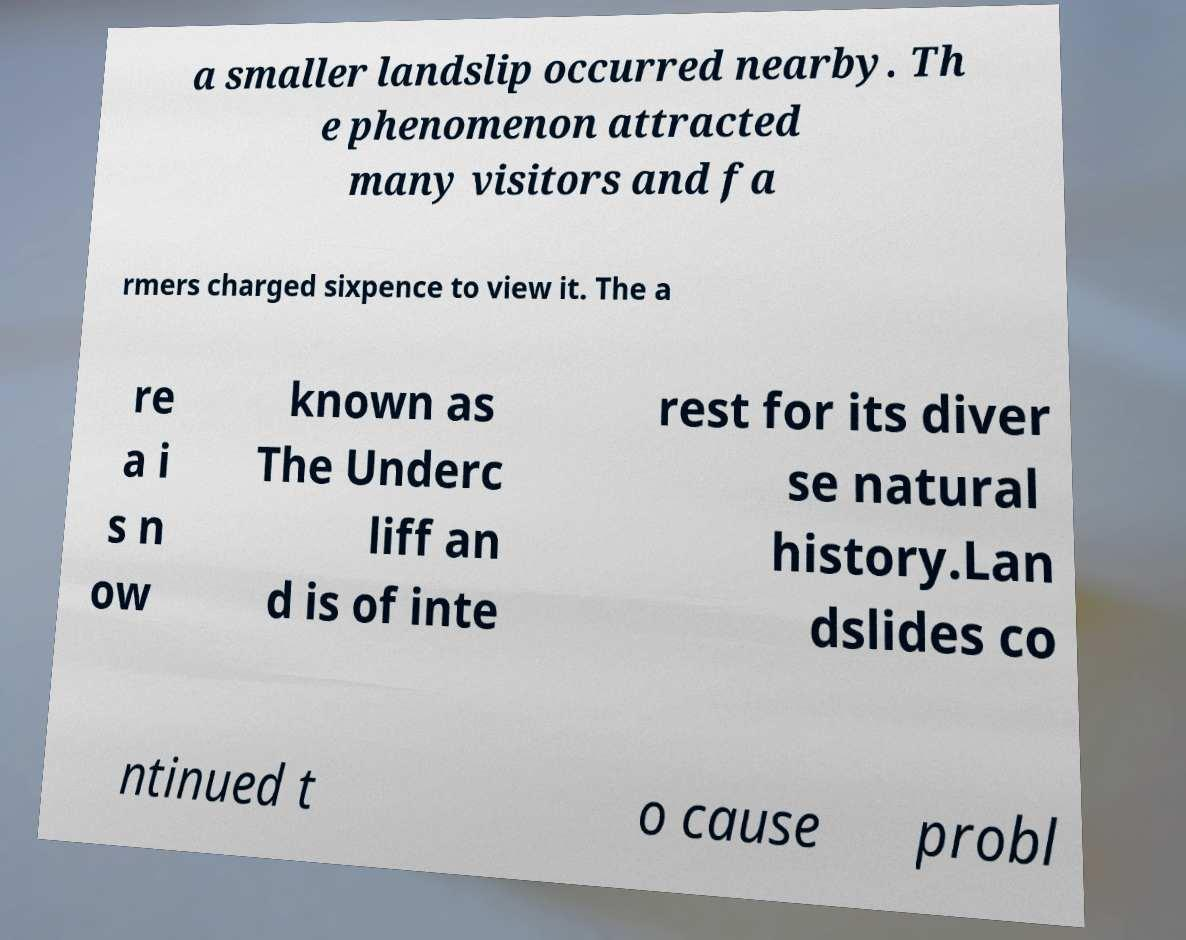Can you read and provide the text displayed in the image?This photo seems to have some interesting text. Can you extract and type it out for me? a smaller landslip occurred nearby. Th e phenomenon attracted many visitors and fa rmers charged sixpence to view it. The a re a i s n ow known as The Underc liff an d is of inte rest for its diver se natural history.Lan dslides co ntinued t o cause probl 